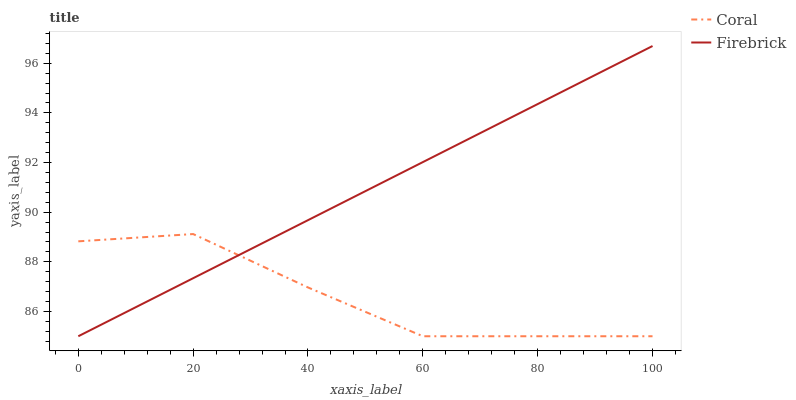Does Coral have the minimum area under the curve?
Answer yes or no. Yes. Does Firebrick have the maximum area under the curve?
Answer yes or no. Yes. Does Firebrick have the minimum area under the curve?
Answer yes or no. No. Is Firebrick the smoothest?
Answer yes or no. Yes. Is Coral the roughest?
Answer yes or no. Yes. Is Firebrick the roughest?
Answer yes or no. No. Does Coral have the lowest value?
Answer yes or no. Yes. Does Firebrick have the highest value?
Answer yes or no. Yes. Does Firebrick intersect Coral?
Answer yes or no. Yes. Is Firebrick less than Coral?
Answer yes or no. No. Is Firebrick greater than Coral?
Answer yes or no. No. 